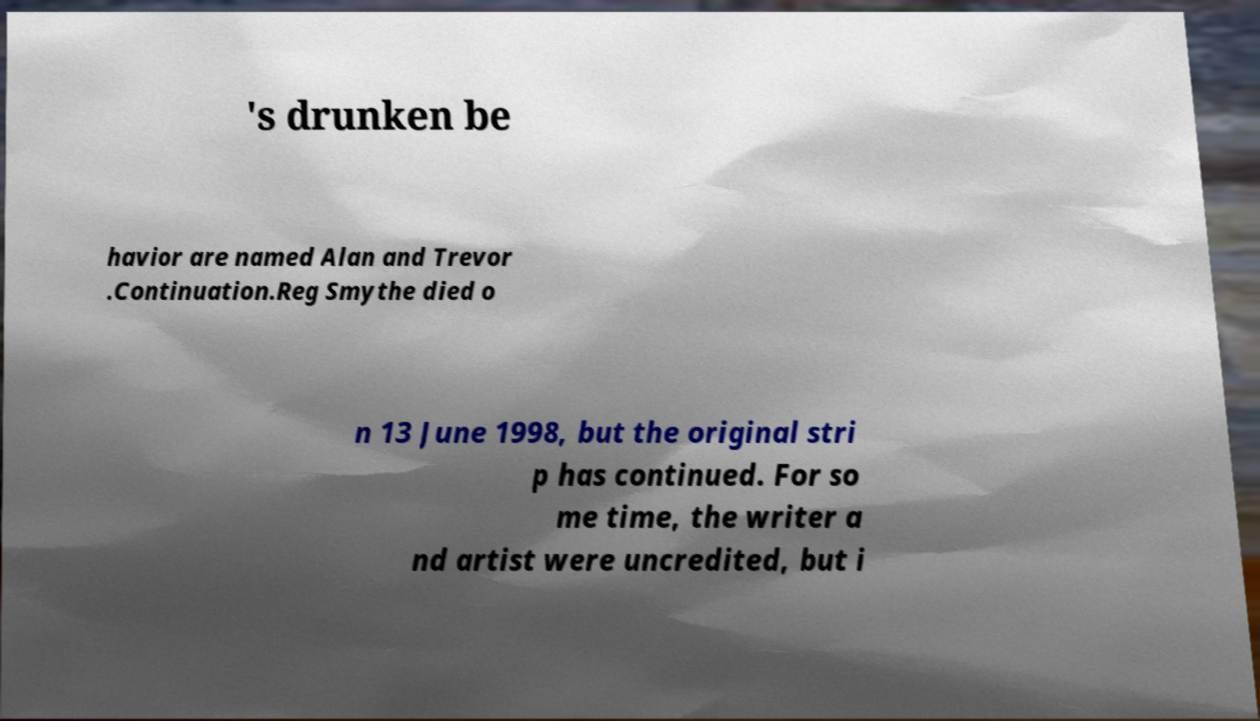For documentation purposes, I need the text within this image transcribed. Could you provide that? 's drunken be havior are named Alan and Trevor .Continuation.Reg Smythe died o n 13 June 1998, but the original stri p has continued. For so me time, the writer a nd artist were uncredited, but i 